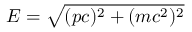Convert formula to latex. <formula><loc_0><loc_0><loc_500><loc_500>E = { \sqrt { ( p c ) ^ { 2 } + ( m c ^ { 2 } ) ^ { 2 } } }</formula> 